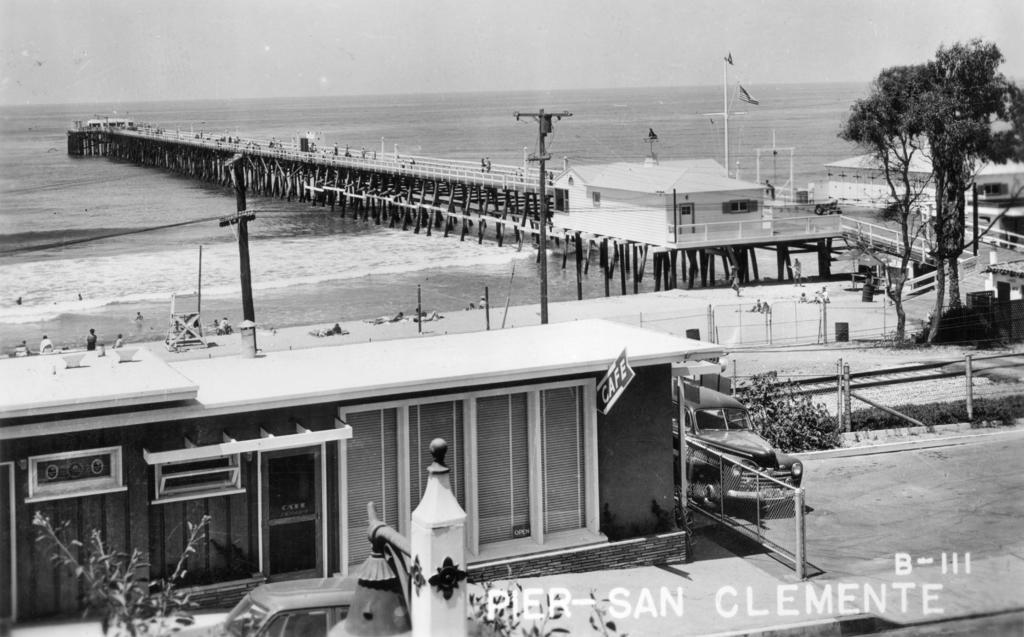Describe this image in one or two sentences. In this picture I can see there is a building here and there is a ocean here, some people are lying on the sand and there is a tree, a bridge here. 